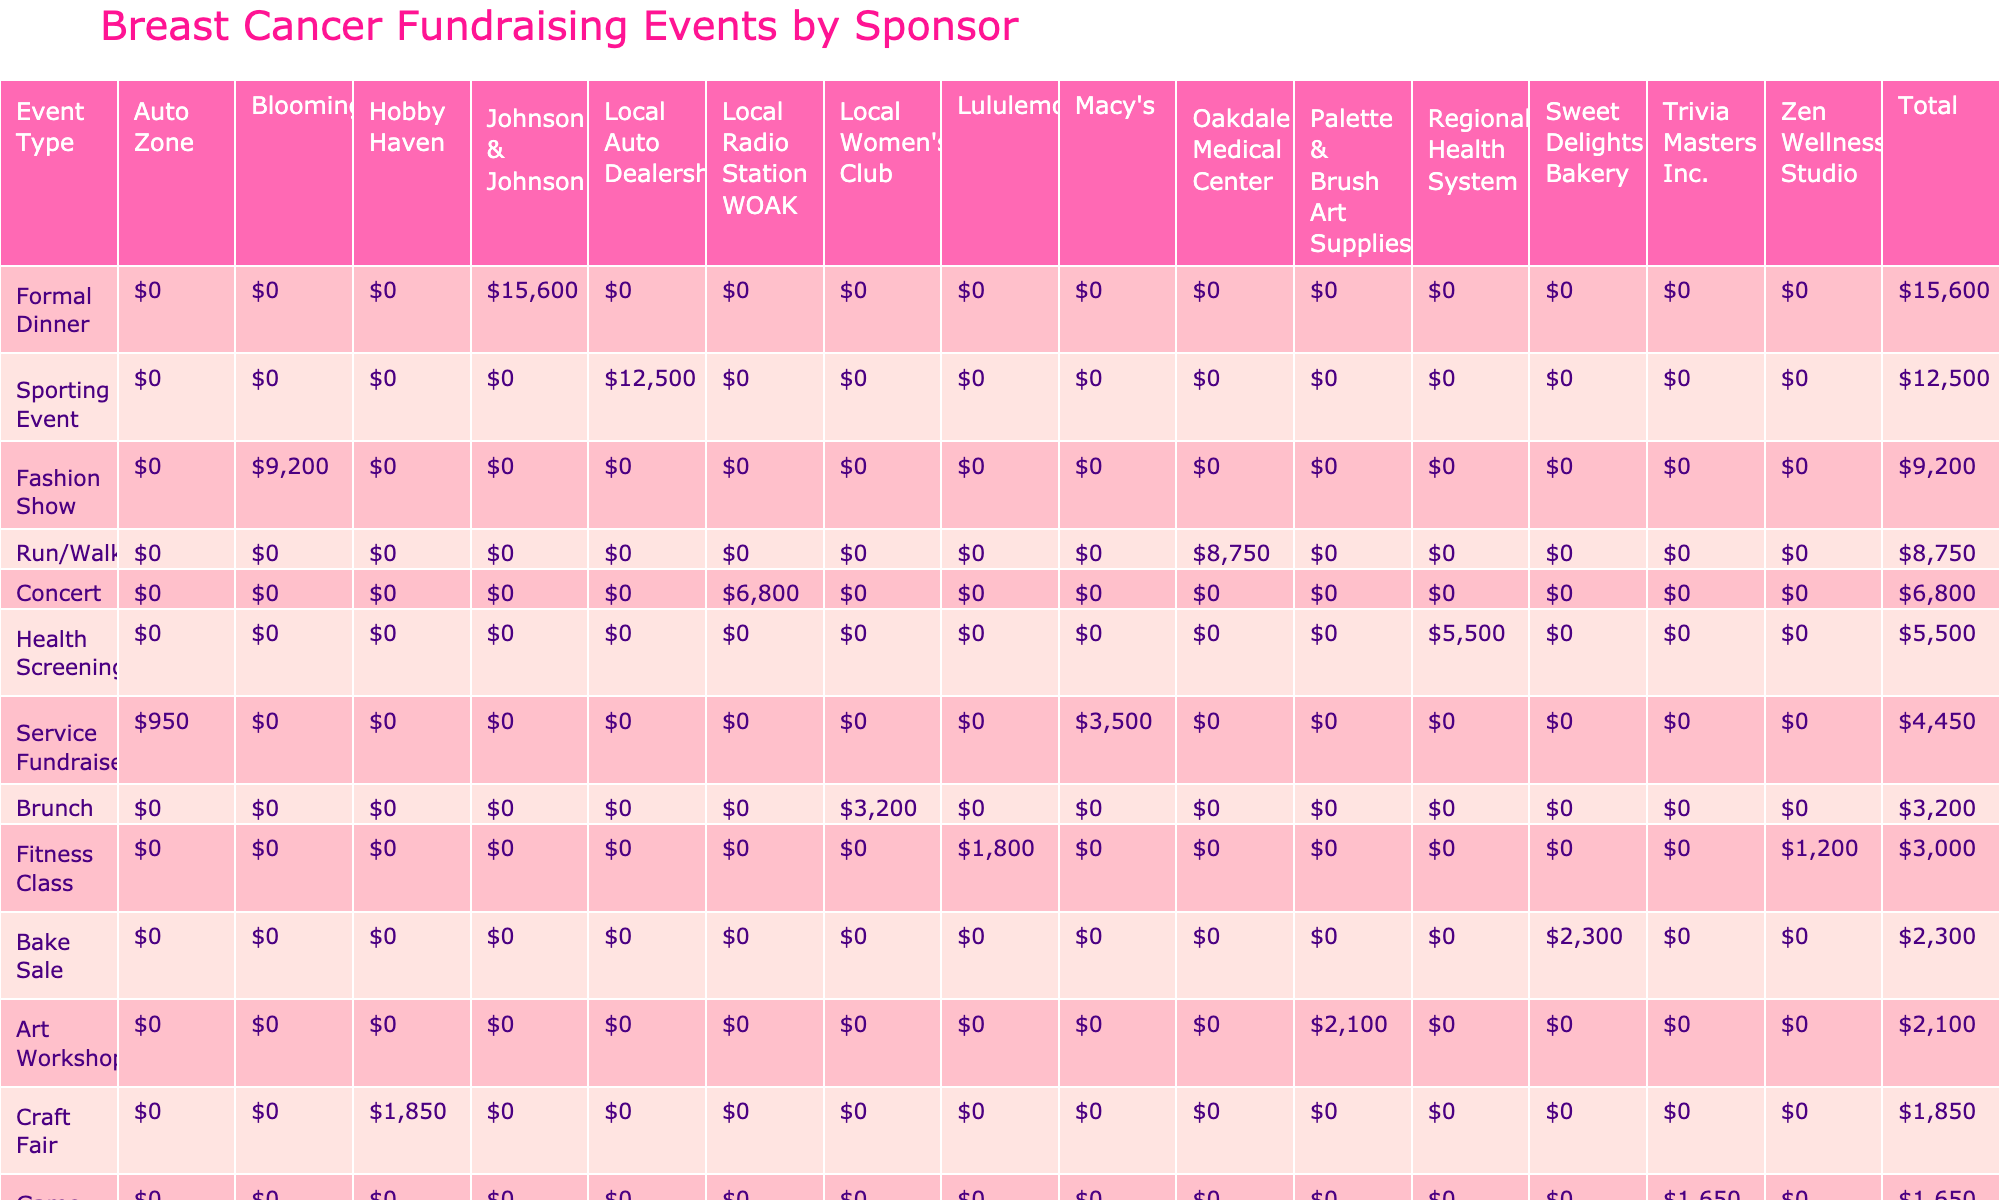What is the total amount raised by the Hope Gala Dinner? The Hope Gala Dinner raised a total of $15,600 as indicated in the table under the respective event row.
Answer: $15,600 Which event type had the highest total raised? To find this, I look at the total raised column and identify the values for each event type. The Formal Dinner (Hope Gala Dinner) has the highest total of $15,600.
Answer: Formal Dinner How much did sporting events raise in total? The only sporting event listed is the Golf Tournament, which raised $12,500. Consequently, the total amount raised from sporting events is $12,500.
Answer: $12,500 Did Auto Zone sponsor any events that raised more than $1,000? The Charity Car Wash event, sponsored by Auto Zone, raised $950, which is not more than $1,000. Therefore, Auto Zone did not sponsor any events that raised more than $1,000.
Answer: No What was the average total raised across all event types? First, I sum all the total raised amounts: $8,750 + $2,300 + $15,600 + $1,850 + $1,200 + $6,800 + $2,100 + $3,500 + $9,200 + $12,500 + $1,650 + $950 + $3,200 + $5,500 + $1,800 = $70,500. There are 14 events, so the average is $70,500 / 14 = $5,035.71.
Answer: $5,035.71 Which sponsor donated the most to breast cancer fundraising events? I look at the total raised associated with each sponsor. Johnson & Johnson contributed $15,600 from the Hope Gala Dinner, and the Local Auto Dealership contributed $12,500 from the Golf Tournament, making Johnson & Johnson the highest contributor.
Answer: Johnson & Johnson 